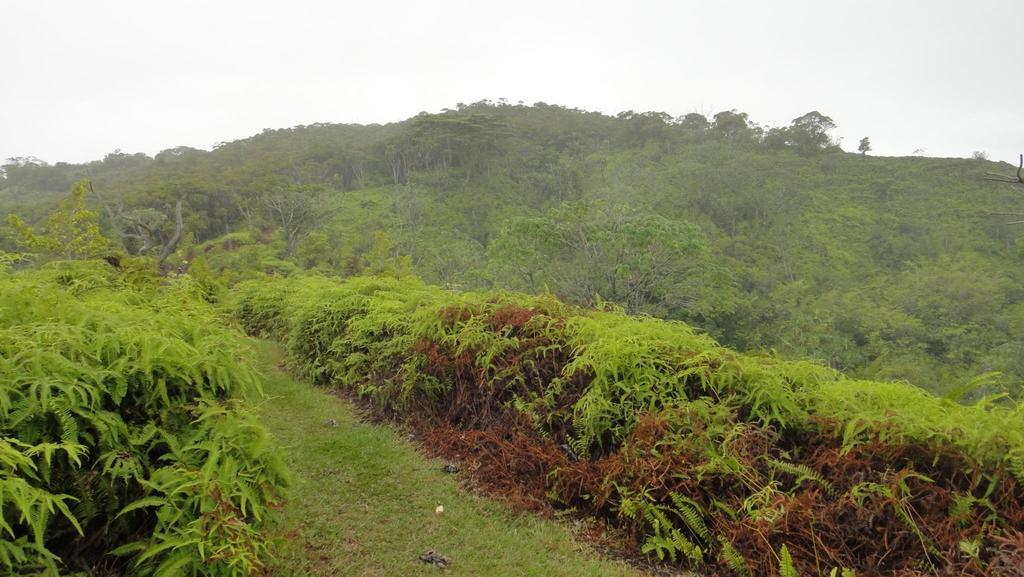What type of vegetation can be seen in the image? There are plants and trees in the image. What is covering the ground in the image? There is grass on the ground in the image. What can be seen in the background of the image? The sky is visible in the background of the image. What type of fish can be seen swimming in the image? There are no fish present in the image; it features plants, trees, grass, and the sky. 